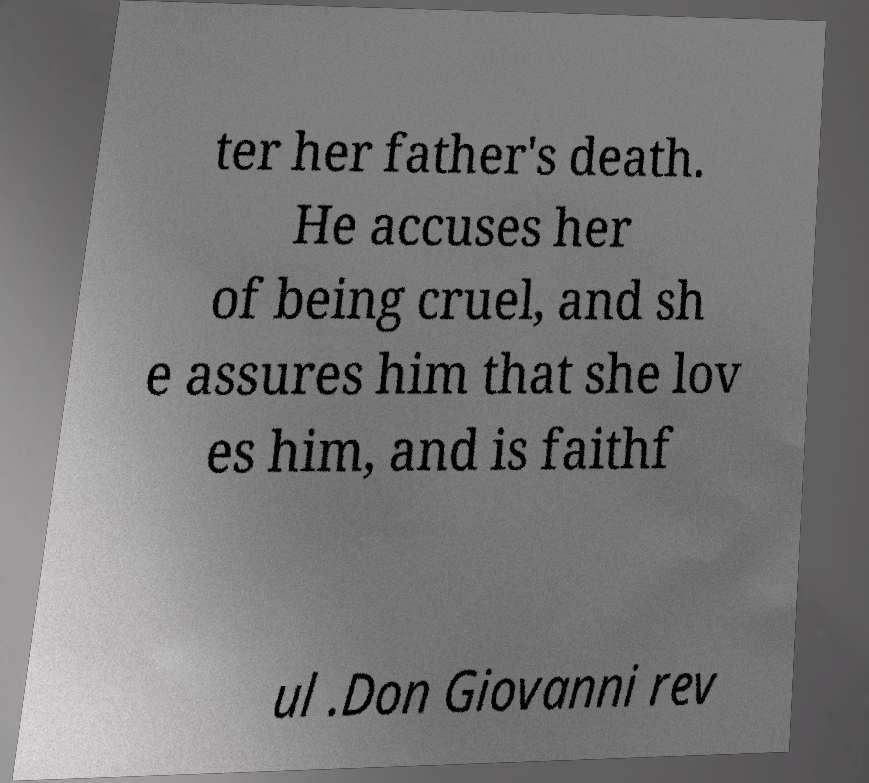For documentation purposes, I need the text within this image transcribed. Could you provide that? ter her father's death. He accuses her of being cruel, and sh e assures him that she lov es him, and is faithf ul .Don Giovanni rev 